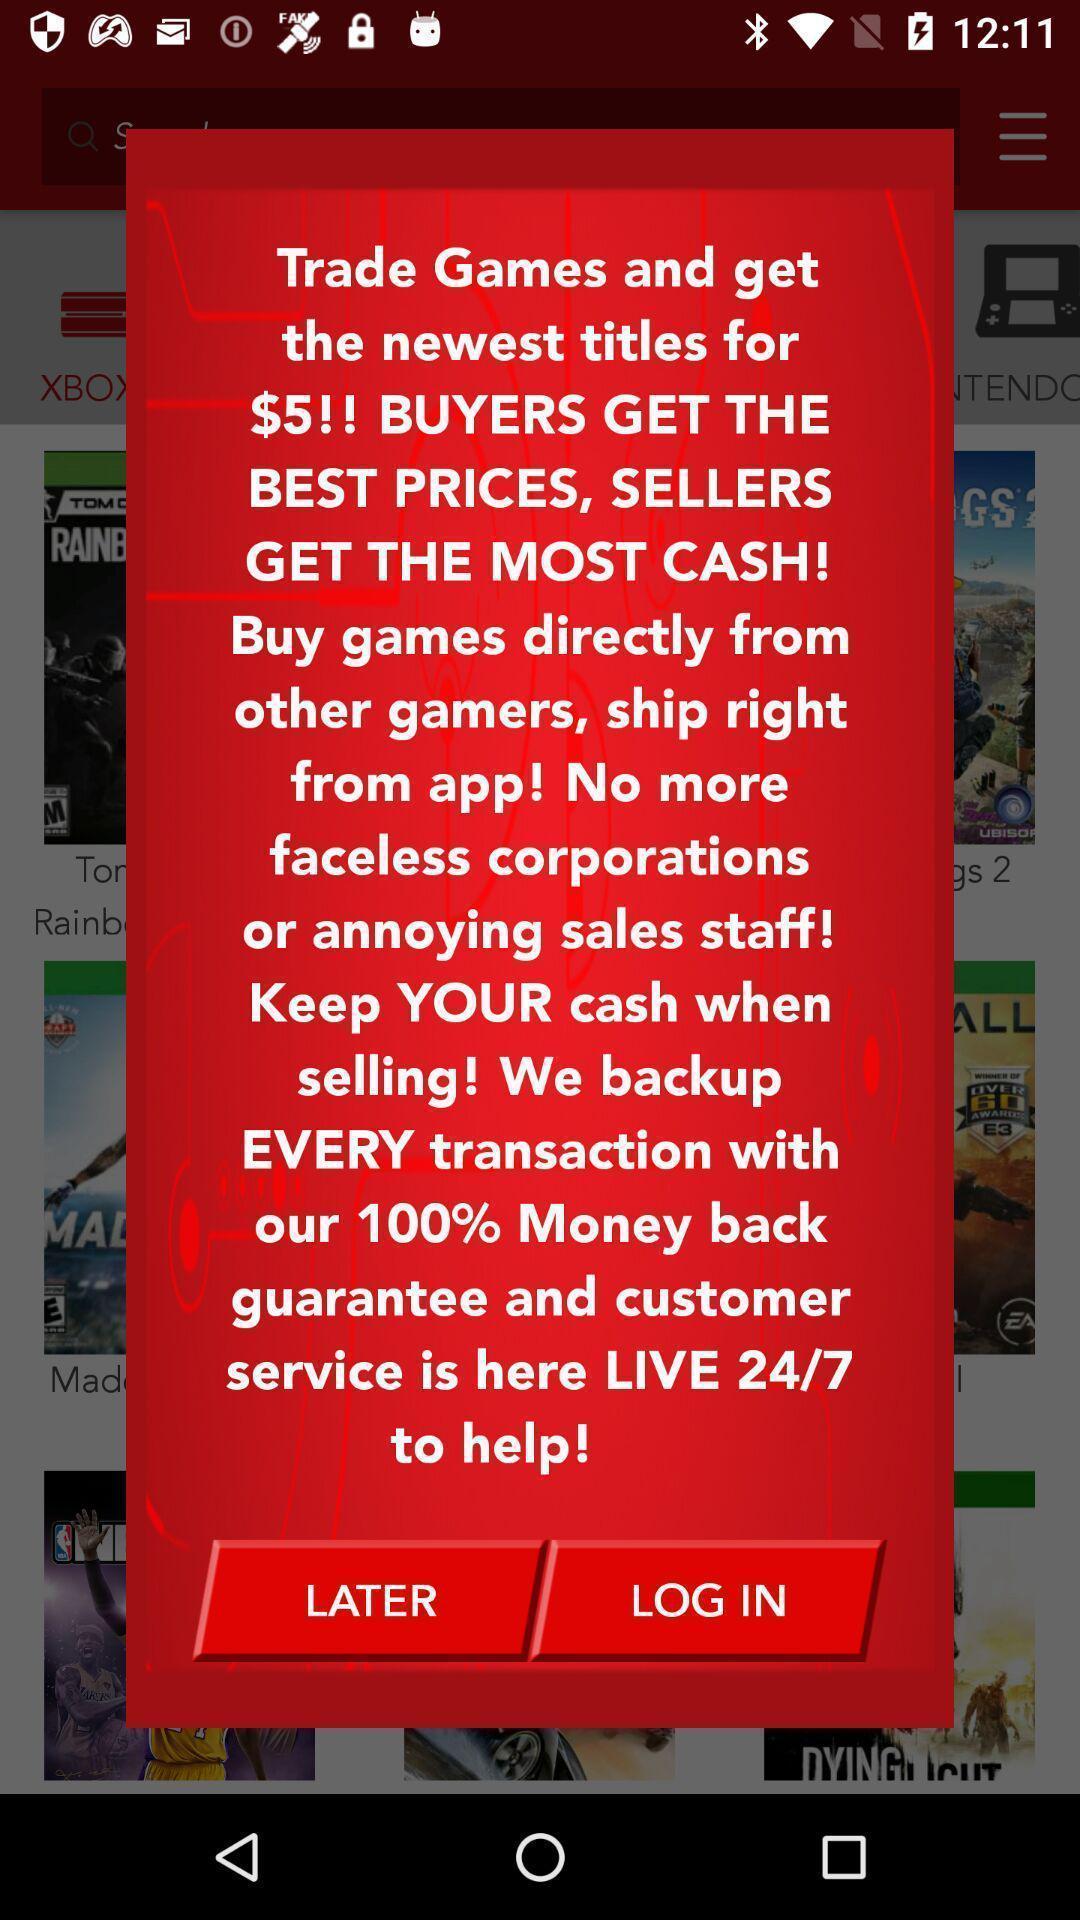Explain what's happening in this screen capture. Popup showing information with later and login option. 